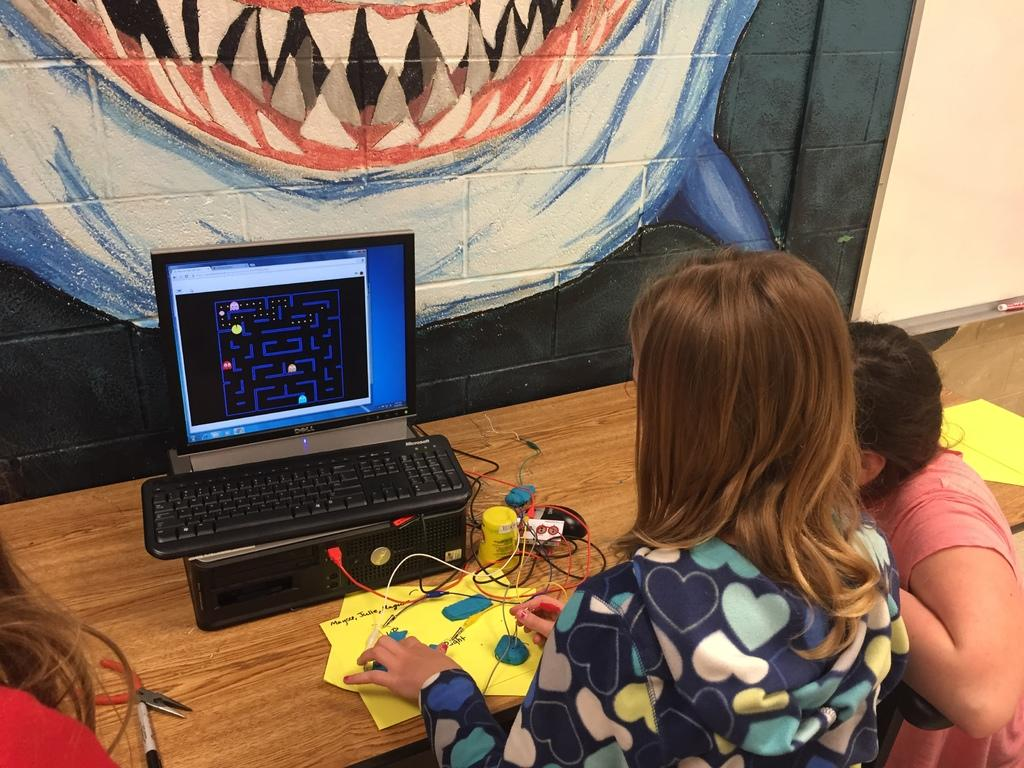How many people are present in the image? There are three persons in the image. What can be seen on the desk in the image? There is a computer and papers on the desk in the image. What is visible in the background of the image? There is a wall and a painting on the wall in the background of the image. What type of muscle is being exercised by the women in the image? There are no women or muscle exercises present in the image. What type of education is being pursued by the persons in the image? The provided facts do not indicate any educational pursuits by the persons in the image. 